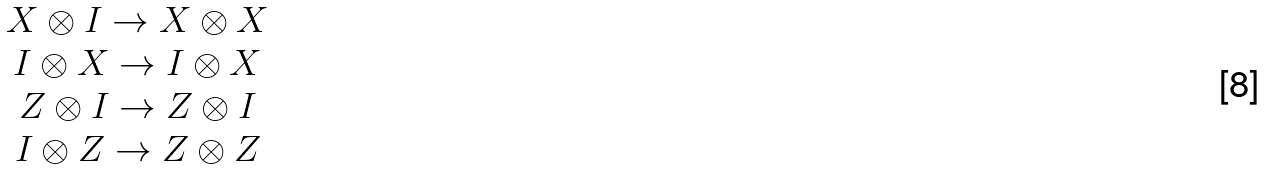<formula> <loc_0><loc_0><loc_500><loc_500>\begin{array} { c } X \otimes I \rightarrow X \otimes X \\ I \otimes X \rightarrow I \otimes X \\ Z \otimes I \rightarrow Z \otimes I \\ I \otimes Z \rightarrow Z \otimes Z \\ \end{array}</formula> 